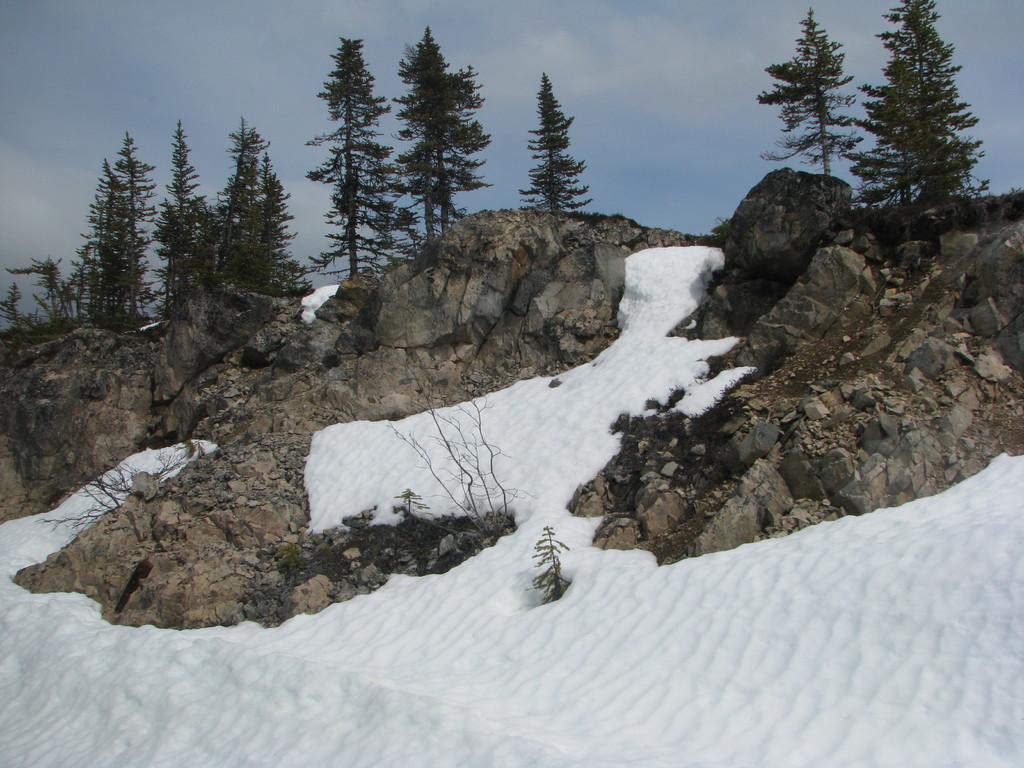Can you describe this image briefly? In this image there is snow on the ground, there are stones and trees and we can see clouds in the sky. 